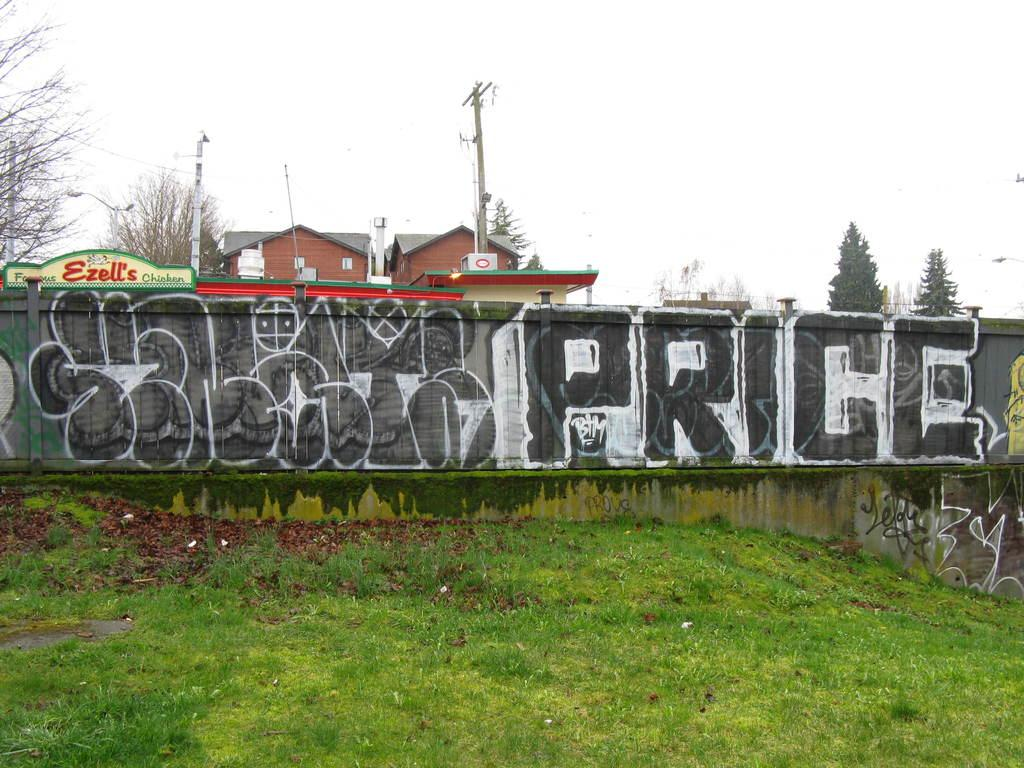What is located behind the grass in the image? There is a wall behind the grass. What can be seen on the wall? Something is painted on the wall. How many houses are visible behind the wall? There are two houses behind the wall. What are the current poles used for near the houses? The current poles are used for electricity near the houses. What type of vegetation is present around the houses? Trees are present around the houses. How many bedrooms are visible in the image? There is no information about bedrooms in the image; it only shows a wall, painted artwork, two houses, current poles, and trees. 